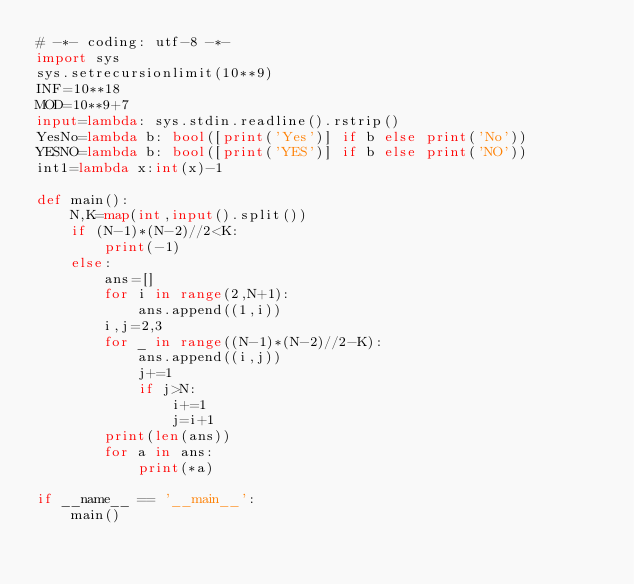<code> <loc_0><loc_0><loc_500><loc_500><_Python_># -*- coding: utf-8 -*-
import sys
sys.setrecursionlimit(10**9)
INF=10**18
MOD=10**9+7
input=lambda: sys.stdin.readline().rstrip()
YesNo=lambda b: bool([print('Yes')] if b else print('No'))
YESNO=lambda b: bool([print('YES')] if b else print('NO'))
int1=lambda x:int(x)-1

def main():
    N,K=map(int,input().split())
    if (N-1)*(N-2)//2<K:
        print(-1)
    else:
        ans=[]
        for i in range(2,N+1):
            ans.append((1,i))
        i,j=2,3
        for _ in range((N-1)*(N-2)//2-K):
            ans.append((i,j))
            j+=1
            if j>N:
                i+=1
                j=i+1
        print(len(ans))
        for a in ans:
            print(*a)

if __name__ == '__main__':
    main()
</code> 